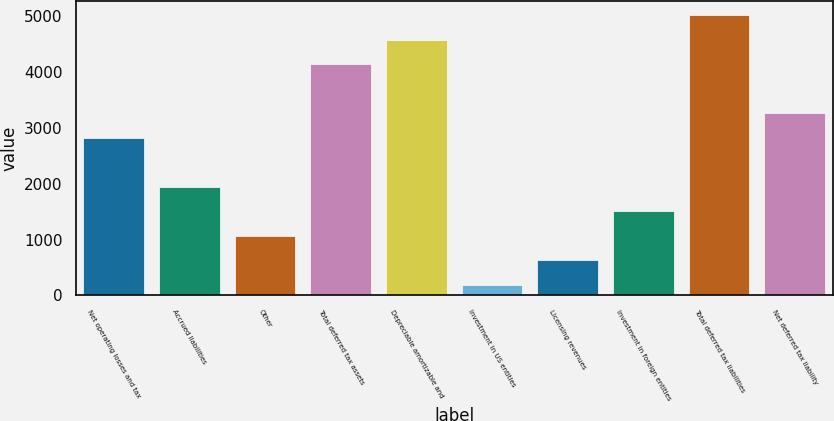<chart> <loc_0><loc_0><loc_500><loc_500><bar_chart><fcel>Net operating losses and tax<fcel>Accrued liabilities<fcel>Other<fcel>Total deferred tax assets<fcel>Depreciable amortizable and<fcel>Investment in US entities<fcel>Licensing revenues<fcel>Investment in foreign entities<fcel>Total deferred tax liabilities<fcel>Net deferred tax liability<nl><fcel>2818.2<fcel>1941.8<fcel>1065.4<fcel>4132.8<fcel>4571<fcel>189<fcel>627.2<fcel>1503.6<fcel>5009.2<fcel>3256.4<nl></chart> 